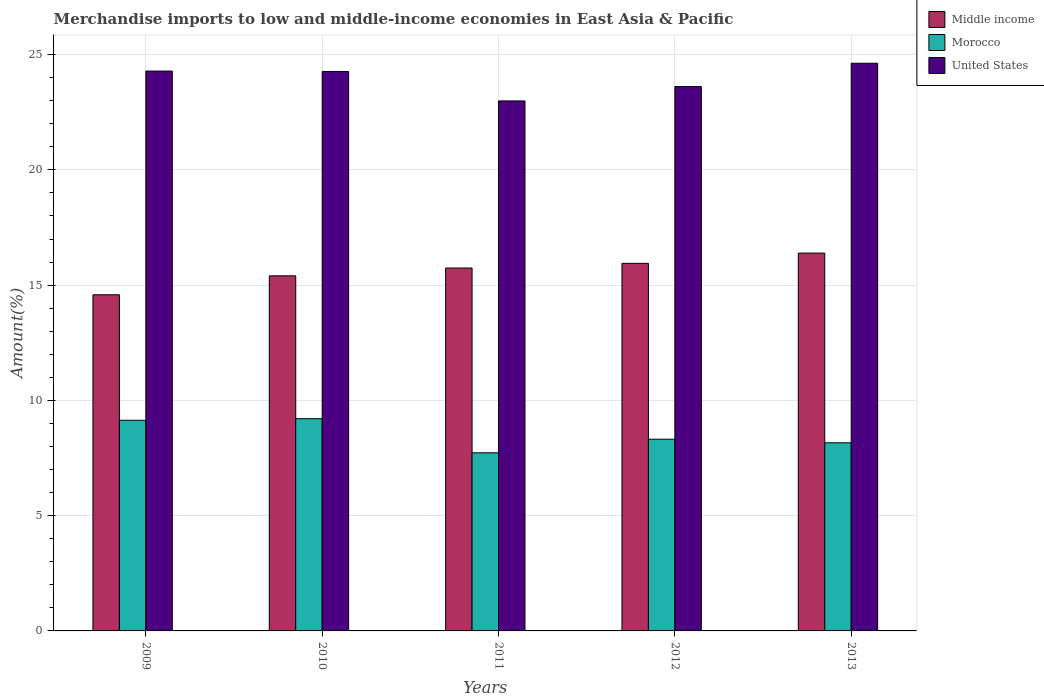How many groups of bars are there?
Ensure brevity in your answer.  5. How many bars are there on the 1st tick from the right?
Your response must be concise. 3. What is the percentage of amount earned from merchandise imports in Middle income in 2013?
Make the answer very short. 16.39. Across all years, what is the maximum percentage of amount earned from merchandise imports in United States?
Provide a short and direct response. 24.62. Across all years, what is the minimum percentage of amount earned from merchandise imports in Morocco?
Provide a succinct answer. 7.73. In which year was the percentage of amount earned from merchandise imports in Morocco maximum?
Offer a terse response. 2010. In which year was the percentage of amount earned from merchandise imports in United States minimum?
Ensure brevity in your answer.  2011. What is the total percentage of amount earned from merchandise imports in Middle income in the graph?
Offer a very short reply. 78.06. What is the difference between the percentage of amount earned from merchandise imports in Morocco in 2010 and that in 2012?
Provide a short and direct response. 0.89. What is the difference between the percentage of amount earned from merchandise imports in United States in 2010 and the percentage of amount earned from merchandise imports in Morocco in 2009?
Your answer should be very brief. 15.13. What is the average percentage of amount earned from merchandise imports in Morocco per year?
Offer a terse response. 8.51. In the year 2011, what is the difference between the percentage of amount earned from merchandise imports in Middle income and percentage of amount earned from merchandise imports in United States?
Provide a short and direct response. -7.25. What is the ratio of the percentage of amount earned from merchandise imports in Morocco in 2010 to that in 2012?
Keep it short and to the point. 1.11. Is the difference between the percentage of amount earned from merchandise imports in Middle income in 2010 and 2013 greater than the difference between the percentage of amount earned from merchandise imports in United States in 2010 and 2013?
Offer a very short reply. No. What is the difference between the highest and the second highest percentage of amount earned from merchandise imports in Morocco?
Make the answer very short. 0.07. What is the difference between the highest and the lowest percentage of amount earned from merchandise imports in United States?
Provide a succinct answer. 1.63. In how many years, is the percentage of amount earned from merchandise imports in United States greater than the average percentage of amount earned from merchandise imports in United States taken over all years?
Your response must be concise. 3. Is the sum of the percentage of amount earned from merchandise imports in Middle income in 2010 and 2012 greater than the maximum percentage of amount earned from merchandise imports in United States across all years?
Provide a short and direct response. Yes. What does the 1st bar from the left in 2012 represents?
Your answer should be very brief. Middle income. How many bars are there?
Offer a very short reply. 15. How many years are there in the graph?
Offer a very short reply. 5. Does the graph contain grids?
Offer a very short reply. Yes. How are the legend labels stacked?
Offer a terse response. Vertical. What is the title of the graph?
Give a very brief answer. Merchandise imports to low and middle-income economies in East Asia & Pacific. Does "Low income" appear as one of the legend labels in the graph?
Provide a short and direct response. No. What is the label or title of the Y-axis?
Your answer should be compact. Amount(%). What is the Amount(%) of Middle income in 2009?
Give a very brief answer. 14.58. What is the Amount(%) in Morocco in 2009?
Give a very brief answer. 9.14. What is the Amount(%) of United States in 2009?
Your answer should be very brief. 24.28. What is the Amount(%) in Middle income in 2010?
Your answer should be very brief. 15.4. What is the Amount(%) of Morocco in 2010?
Provide a succinct answer. 9.21. What is the Amount(%) in United States in 2010?
Provide a short and direct response. 24.27. What is the Amount(%) in Middle income in 2011?
Provide a succinct answer. 15.74. What is the Amount(%) in Morocco in 2011?
Provide a succinct answer. 7.73. What is the Amount(%) of United States in 2011?
Your response must be concise. 22.99. What is the Amount(%) in Middle income in 2012?
Offer a very short reply. 15.94. What is the Amount(%) in Morocco in 2012?
Offer a terse response. 8.31. What is the Amount(%) of United States in 2012?
Make the answer very short. 23.61. What is the Amount(%) of Middle income in 2013?
Keep it short and to the point. 16.39. What is the Amount(%) in Morocco in 2013?
Your answer should be very brief. 8.16. What is the Amount(%) in United States in 2013?
Offer a terse response. 24.62. Across all years, what is the maximum Amount(%) in Middle income?
Ensure brevity in your answer.  16.39. Across all years, what is the maximum Amount(%) in Morocco?
Provide a short and direct response. 9.21. Across all years, what is the maximum Amount(%) of United States?
Provide a short and direct response. 24.62. Across all years, what is the minimum Amount(%) of Middle income?
Provide a short and direct response. 14.58. Across all years, what is the minimum Amount(%) in Morocco?
Provide a short and direct response. 7.73. Across all years, what is the minimum Amount(%) in United States?
Make the answer very short. 22.99. What is the total Amount(%) in Middle income in the graph?
Your response must be concise. 78.06. What is the total Amount(%) of Morocco in the graph?
Your response must be concise. 42.55. What is the total Amount(%) in United States in the graph?
Your response must be concise. 119.78. What is the difference between the Amount(%) of Middle income in 2009 and that in 2010?
Offer a very short reply. -0.82. What is the difference between the Amount(%) of Morocco in 2009 and that in 2010?
Give a very brief answer. -0.07. What is the difference between the Amount(%) of United States in 2009 and that in 2010?
Your answer should be compact. 0.02. What is the difference between the Amount(%) in Middle income in 2009 and that in 2011?
Give a very brief answer. -1.16. What is the difference between the Amount(%) of Morocco in 2009 and that in 2011?
Offer a terse response. 1.41. What is the difference between the Amount(%) in United States in 2009 and that in 2011?
Your answer should be very brief. 1.3. What is the difference between the Amount(%) in Middle income in 2009 and that in 2012?
Keep it short and to the point. -1.36. What is the difference between the Amount(%) of Morocco in 2009 and that in 2012?
Provide a succinct answer. 0.82. What is the difference between the Amount(%) in United States in 2009 and that in 2012?
Make the answer very short. 0.67. What is the difference between the Amount(%) in Middle income in 2009 and that in 2013?
Offer a terse response. -1.81. What is the difference between the Amount(%) of United States in 2009 and that in 2013?
Your answer should be very brief. -0.34. What is the difference between the Amount(%) of Middle income in 2010 and that in 2011?
Provide a short and direct response. -0.34. What is the difference between the Amount(%) in Morocco in 2010 and that in 2011?
Offer a terse response. 1.48. What is the difference between the Amount(%) in United States in 2010 and that in 2011?
Give a very brief answer. 1.28. What is the difference between the Amount(%) of Middle income in 2010 and that in 2012?
Your answer should be compact. -0.54. What is the difference between the Amount(%) in Morocco in 2010 and that in 2012?
Make the answer very short. 0.89. What is the difference between the Amount(%) in United States in 2010 and that in 2012?
Ensure brevity in your answer.  0.65. What is the difference between the Amount(%) of Middle income in 2010 and that in 2013?
Ensure brevity in your answer.  -0.99. What is the difference between the Amount(%) in Morocco in 2010 and that in 2013?
Make the answer very short. 1.05. What is the difference between the Amount(%) of United States in 2010 and that in 2013?
Your response must be concise. -0.36. What is the difference between the Amount(%) of Middle income in 2011 and that in 2012?
Offer a very short reply. -0.2. What is the difference between the Amount(%) in Morocco in 2011 and that in 2012?
Make the answer very short. -0.59. What is the difference between the Amount(%) of United States in 2011 and that in 2012?
Your answer should be compact. -0.62. What is the difference between the Amount(%) in Middle income in 2011 and that in 2013?
Your answer should be very brief. -0.65. What is the difference between the Amount(%) in Morocco in 2011 and that in 2013?
Keep it short and to the point. -0.43. What is the difference between the Amount(%) of United States in 2011 and that in 2013?
Keep it short and to the point. -1.63. What is the difference between the Amount(%) of Middle income in 2012 and that in 2013?
Offer a terse response. -0.44. What is the difference between the Amount(%) of Morocco in 2012 and that in 2013?
Your answer should be compact. 0.15. What is the difference between the Amount(%) in United States in 2012 and that in 2013?
Your answer should be very brief. -1.01. What is the difference between the Amount(%) of Middle income in 2009 and the Amount(%) of Morocco in 2010?
Offer a very short reply. 5.37. What is the difference between the Amount(%) of Middle income in 2009 and the Amount(%) of United States in 2010?
Your response must be concise. -9.69. What is the difference between the Amount(%) of Morocco in 2009 and the Amount(%) of United States in 2010?
Give a very brief answer. -15.13. What is the difference between the Amount(%) in Middle income in 2009 and the Amount(%) in Morocco in 2011?
Give a very brief answer. 6.85. What is the difference between the Amount(%) of Middle income in 2009 and the Amount(%) of United States in 2011?
Your response must be concise. -8.41. What is the difference between the Amount(%) in Morocco in 2009 and the Amount(%) in United States in 2011?
Your answer should be very brief. -13.85. What is the difference between the Amount(%) in Middle income in 2009 and the Amount(%) in Morocco in 2012?
Provide a succinct answer. 6.27. What is the difference between the Amount(%) of Middle income in 2009 and the Amount(%) of United States in 2012?
Provide a short and direct response. -9.03. What is the difference between the Amount(%) in Morocco in 2009 and the Amount(%) in United States in 2012?
Offer a very short reply. -14.48. What is the difference between the Amount(%) in Middle income in 2009 and the Amount(%) in Morocco in 2013?
Offer a very short reply. 6.42. What is the difference between the Amount(%) of Middle income in 2009 and the Amount(%) of United States in 2013?
Your answer should be compact. -10.04. What is the difference between the Amount(%) of Morocco in 2009 and the Amount(%) of United States in 2013?
Ensure brevity in your answer.  -15.49. What is the difference between the Amount(%) in Middle income in 2010 and the Amount(%) in Morocco in 2011?
Provide a succinct answer. 7.68. What is the difference between the Amount(%) in Middle income in 2010 and the Amount(%) in United States in 2011?
Keep it short and to the point. -7.59. What is the difference between the Amount(%) of Morocco in 2010 and the Amount(%) of United States in 2011?
Provide a succinct answer. -13.78. What is the difference between the Amount(%) in Middle income in 2010 and the Amount(%) in Morocco in 2012?
Give a very brief answer. 7.09. What is the difference between the Amount(%) in Middle income in 2010 and the Amount(%) in United States in 2012?
Your answer should be very brief. -8.21. What is the difference between the Amount(%) in Morocco in 2010 and the Amount(%) in United States in 2012?
Make the answer very short. -14.41. What is the difference between the Amount(%) of Middle income in 2010 and the Amount(%) of Morocco in 2013?
Keep it short and to the point. 7.24. What is the difference between the Amount(%) in Middle income in 2010 and the Amount(%) in United States in 2013?
Keep it short and to the point. -9.22. What is the difference between the Amount(%) in Morocco in 2010 and the Amount(%) in United States in 2013?
Provide a succinct answer. -15.42. What is the difference between the Amount(%) of Middle income in 2011 and the Amount(%) of Morocco in 2012?
Provide a succinct answer. 7.43. What is the difference between the Amount(%) in Middle income in 2011 and the Amount(%) in United States in 2012?
Offer a terse response. -7.87. What is the difference between the Amount(%) in Morocco in 2011 and the Amount(%) in United States in 2012?
Your response must be concise. -15.89. What is the difference between the Amount(%) in Middle income in 2011 and the Amount(%) in Morocco in 2013?
Provide a short and direct response. 7.58. What is the difference between the Amount(%) in Middle income in 2011 and the Amount(%) in United States in 2013?
Your response must be concise. -8.88. What is the difference between the Amount(%) in Morocco in 2011 and the Amount(%) in United States in 2013?
Make the answer very short. -16.9. What is the difference between the Amount(%) in Middle income in 2012 and the Amount(%) in Morocco in 2013?
Your answer should be compact. 7.78. What is the difference between the Amount(%) in Middle income in 2012 and the Amount(%) in United States in 2013?
Your response must be concise. -8.68. What is the difference between the Amount(%) in Morocco in 2012 and the Amount(%) in United States in 2013?
Keep it short and to the point. -16.31. What is the average Amount(%) of Middle income per year?
Keep it short and to the point. 15.61. What is the average Amount(%) of Morocco per year?
Give a very brief answer. 8.51. What is the average Amount(%) in United States per year?
Your answer should be compact. 23.96. In the year 2009, what is the difference between the Amount(%) in Middle income and Amount(%) in Morocco?
Keep it short and to the point. 5.44. In the year 2009, what is the difference between the Amount(%) in Middle income and Amount(%) in United States?
Make the answer very short. -9.7. In the year 2009, what is the difference between the Amount(%) in Morocco and Amount(%) in United States?
Give a very brief answer. -15.15. In the year 2010, what is the difference between the Amount(%) of Middle income and Amount(%) of Morocco?
Provide a succinct answer. 6.2. In the year 2010, what is the difference between the Amount(%) in Middle income and Amount(%) in United States?
Your answer should be very brief. -8.86. In the year 2010, what is the difference between the Amount(%) of Morocco and Amount(%) of United States?
Provide a succinct answer. -15.06. In the year 2011, what is the difference between the Amount(%) of Middle income and Amount(%) of Morocco?
Offer a very short reply. 8.01. In the year 2011, what is the difference between the Amount(%) in Middle income and Amount(%) in United States?
Offer a very short reply. -7.25. In the year 2011, what is the difference between the Amount(%) in Morocco and Amount(%) in United States?
Give a very brief answer. -15.26. In the year 2012, what is the difference between the Amount(%) in Middle income and Amount(%) in Morocco?
Your answer should be compact. 7.63. In the year 2012, what is the difference between the Amount(%) in Middle income and Amount(%) in United States?
Offer a terse response. -7.67. In the year 2012, what is the difference between the Amount(%) of Morocco and Amount(%) of United States?
Provide a succinct answer. -15.3. In the year 2013, what is the difference between the Amount(%) in Middle income and Amount(%) in Morocco?
Offer a very short reply. 8.23. In the year 2013, what is the difference between the Amount(%) in Middle income and Amount(%) in United States?
Offer a very short reply. -8.23. In the year 2013, what is the difference between the Amount(%) of Morocco and Amount(%) of United States?
Provide a succinct answer. -16.46. What is the ratio of the Amount(%) of Middle income in 2009 to that in 2010?
Ensure brevity in your answer.  0.95. What is the ratio of the Amount(%) in Morocco in 2009 to that in 2010?
Give a very brief answer. 0.99. What is the ratio of the Amount(%) of United States in 2009 to that in 2010?
Your answer should be very brief. 1. What is the ratio of the Amount(%) in Middle income in 2009 to that in 2011?
Your answer should be compact. 0.93. What is the ratio of the Amount(%) in Morocco in 2009 to that in 2011?
Offer a very short reply. 1.18. What is the ratio of the Amount(%) in United States in 2009 to that in 2011?
Offer a very short reply. 1.06. What is the ratio of the Amount(%) of Middle income in 2009 to that in 2012?
Ensure brevity in your answer.  0.91. What is the ratio of the Amount(%) in Morocco in 2009 to that in 2012?
Offer a very short reply. 1.1. What is the ratio of the Amount(%) in United States in 2009 to that in 2012?
Your answer should be very brief. 1.03. What is the ratio of the Amount(%) of Middle income in 2009 to that in 2013?
Your answer should be very brief. 0.89. What is the ratio of the Amount(%) in Morocco in 2009 to that in 2013?
Provide a succinct answer. 1.12. What is the ratio of the Amount(%) in United States in 2009 to that in 2013?
Keep it short and to the point. 0.99. What is the ratio of the Amount(%) of Middle income in 2010 to that in 2011?
Your answer should be very brief. 0.98. What is the ratio of the Amount(%) in Morocco in 2010 to that in 2011?
Provide a short and direct response. 1.19. What is the ratio of the Amount(%) of United States in 2010 to that in 2011?
Provide a succinct answer. 1.06. What is the ratio of the Amount(%) in Middle income in 2010 to that in 2012?
Your answer should be compact. 0.97. What is the ratio of the Amount(%) in Morocco in 2010 to that in 2012?
Keep it short and to the point. 1.11. What is the ratio of the Amount(%) in United States in 2010 to that in 2012?
Offer a very short reply. 1.03. What is the ratio of the Amount(%) of Middle income in 2010 to that in 2013?
Provide a short and direct response. 0.94. What is the ratio of the Amount(%) in Morocco in 2010 to that in 2013?
Your answer should be compact. 1.13. What is the ratio of the Amount(%) in United States in 2010 to that in 2013?
Make the answer very short. 0.99. What is the ratio of the Amount(%) in Middle income in 2011 to that in 2012?
Make the answer very short. 0.99. What is the ratio of the Amount(%) in Morocco in 2011 to that in 2012?
Provide a short and direct response. 0.93. What is the ratio of the Amount(%) of United States in 2011 to that in 2012?
Keep it short and to the point. 0.97. What is the ratio of the Amount(%) of Middle income in 2011 to that in 2013?
Keep it short and to the point. 0.96. What is the ratio of the Amount(%) in Morocco in 2011 to that in 2013?
Offer a very short reply. 0.95. What is the ratio of the Amount(%) of United States in 2011 to that in 2013?
Keep it short and to the point. 0.93. What is the ratio of the Amount(%) of Middle income in 2012 to that in 2013?
Provide a short and direct response. 0.97. What is the ratio of the Amount(%) of Morocco in 2012 to that in 2013?
Ensure brevity in your answer.  1.02. What is the ratio of the Amount(%) of United States in 2012 to that in 2013?
Offer a terse response. 0.96. What is the difference between the highest and the second highest Amount(%) of Middle income?
Offer a terse response. 0.44. What is the difference between the highest and the second highest Amount(%) of Morocco?
Your answer should be very brief. 0.07. What is the difference between the highest and the second highest Amount(%) of United States?
Make the answer very short. 0.34. What is the difference between the highest and the lowest Amount(%) of Middle income?
Offer a very short reply. 1.81. What is the difference between the highest and the lowest Amount(%) of Morocco?
Offer a terse response. 1.48. What is the difference between the highest and the lowest Amount(%) of United States?
Offer a terse response. 1.63. 